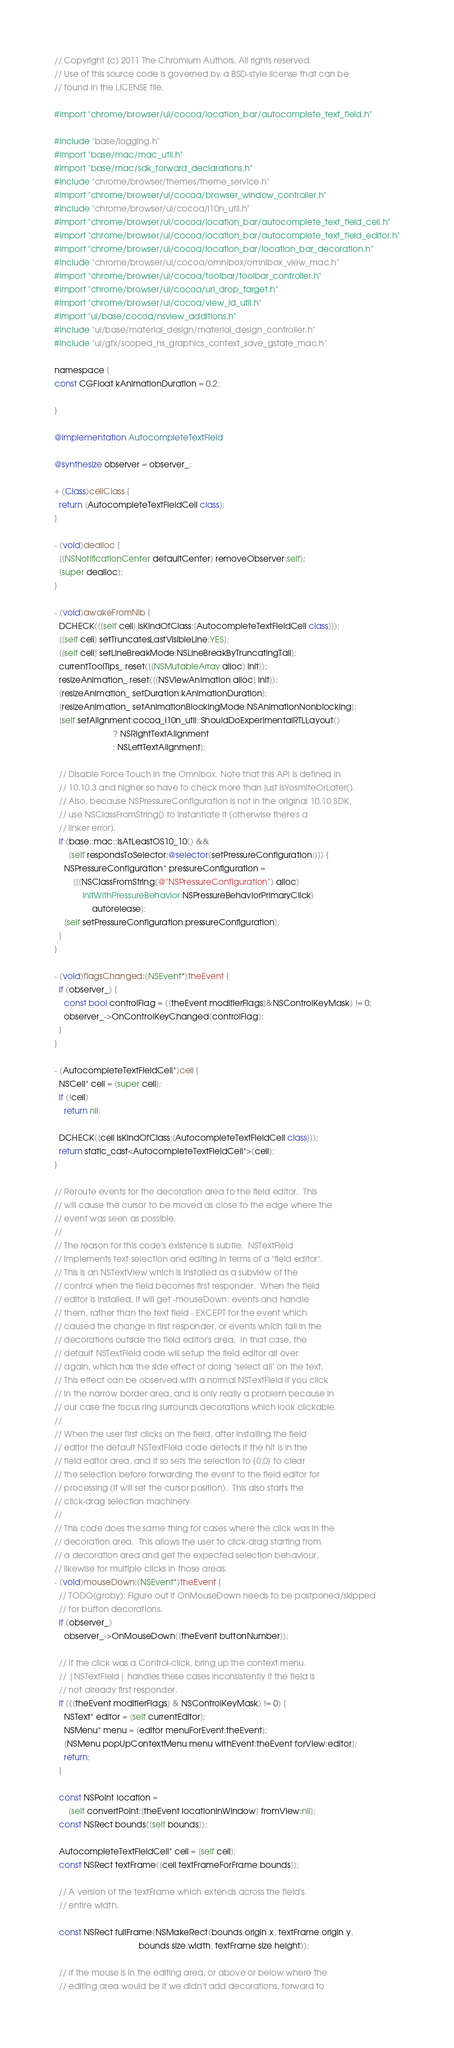<code> <loc_0><loc_0><loc_500><loc_500><_ObjectiveC_>// Copyright (c) 2011 The Chromium Authors. All rights reserved.
// Use of this source code is governed by a BSD-style license that can be
// found in the LICENSE file.

#import "chrome/browser/ui/cocoa/location_bar/autocomplete_text_field.h"

#include "base/logging.h"
#import "base/mac/mac_util.h"
#import "base/mac/sdk_forward_declarations.h"
#include "chrome/browser/themes/theme_service.h"
#import "chrome/browser/ui/cocoa/browser_window_controller.h"
#include "chrome/browser/ui/cocoa/l10n_util.h"
#import "chrome/browser/ui/cocoa/location_bar/autocomplete_text_field_cell.h"
#import "chrome/browser/ui/cocoa/location_bar/autocomplete_text_field_editor.h"
#import "chrome/browser/ui/cocoa/location_bar/location_bar_decoration.h"
#include "chrome/browser/ui/cocoa/omnibox/omnibox_view_mac.h"
#import "chrome/browser/ui/cocoa/toolbar/toolbar_controller.h"
#import "chrome/browser/ui/cocoa/url_drop_target.h"
#import "chrome/browser/ui/cocoa/view_id_util.h"
#import "ui/base/cocoa/nsview_additions.h"
#include "ui/base/material_design/material_design_controller.h"
#include "ui/gfx/scoped_ns_graphics_context_save_gstate_mac.h"

namespace {
const CGFloat kAnimationDuration = 0.2;

}

@implementation AutocompleteTextField

@synthesize observer = observer_;

+ (Class)cellClass {
  return [AutocompleteTextFieldCell class];
}

- (void)dealloc {
  [[NSNotificationCenter defaultCenter] removeObserver:self];
  [super dealloc];
}

- (void)awakeFromNib {
  DCHECK([[self cell] isKindOfClass:[AutocompleteTextFieldCell class]]);
  [[self cell] setTruncatesLastVisibleLine:YES];
  [[self cell] setLineBreakMode:NSLineBreakByTruncatingTail];
  currentToolTips_.reset([[NSMutableArray alloc] init]);
  resizeAnimation_.reset([[NSViewAnimation alloc] init]);
  [resizeAnimation_ setDuration:kAnimationDuration];
  [resizeAnimation_ setAnimationBlockingMode:NSAnimationNonblocking];
  [self setAlignment:cocoa_l10n_util::ShouldDoExperimentalRTLLayout()
                         ? NSRightTextAlignment
                         : NSLeftTextAlignment];

  // Disable Force Touch in the Omnibox. Note that this API is defined in
  // 10.10.3 and higher so have to check more than just isYosmiteOrLater().
  // Also, because NSPressureConfiguration is not in the original 10.10 SDK,
  // use NSClassFromString() to instantiate it (otherwise there's a
  // linker error).
  if (base::mac::IsAtLeastOS10_10() &&
      [self respondsToSelector:@selector(setPressureConfiguration:)]) {
    NSPressureConfiguration* pressureConfiguration =
        [[[NSClassFromString(@"NSPressureConfiguration") alloc]
            initWithPressureBehavior:NSPressureBehaviorPrimaryClick]
                autorelease];
    [self setPressureConfiguration:pressureConfiguration];
  }
}

- (void)flagsChanged:(NSEvent*)theEvent {
  if (observer_) {
    const bool controlFlag = ([theEvent modifierFlags]&NSControlKeyMask) != 0;
    observer_->OnControlKeyChanged(controlFlag);
  }
}

- (AutocompleteTextFieldCell*)cell {
  NSCell* cell = [super cell];
  if (!cell)
    return nil;

  DCHECK([cell isKindOfClass:[AutocompleteTextFieldCell class]]);
  return static_cast<AutocompleteTextFieldCell*>(cell);
}

// Reroute events for the decoration area to the field editor.  This
// will cause the cursor to be moved as close to the edge where the
// event was seen as possible.
//
// The reason for this code's existence is subtle.  NSTextField
// implements text selection and editing in terms of a "field editor".
// This is an NSTextView which is installed as a subview of the
// control when the field becomes first responder.  When the field
// editor is installed, it will get -mouseDown: events and handle
// them, rather than the text field - EXCEPT for the event which
// caused the change in first responder, or events which fall in the
// decorations outside the field editor's area.  In that case, the
// default NSTextField code will setup the field editor all over
// again, which has the side effect of doing "select all" on the text.
// This effect can be observed with a normal NSTextField if you click
// in the narrow border area, and is only really a problem because in
// our case the focus ring surrounds decorations which look clickable.
//
// When the user first clicks on the field, after installing the field
// editor the default NSTextField code detects if the hit is in the
// field editor area, and if so sets the selection to {0,0} to clear
// the selection before forwarding the event to the field editor for
// processing (it will set the cursor position).  This also starts the
// click-drag selection machinery.
//
// This code does the same thing for cases where the click was in the
// decoration area.  This allows the user to click-drag starting from
// a decoration area and get the expected selection behaviour,
// likewise for multiple clicks in those areas.
- (void)mouseDown:(NSEvent*)theEvent {
  // TODO(groby): Figure out if OnMouseDown needs to be postponed/skipped
  // for button decorations.
  if (observer_)
    observer_->OnMouseDown([theEvent buttonNumber]);

  // If the click was a Control-click, bring up the context menu.
  // |NSTextField| handles these cases inconsistently if the field is
  // not already first responder.
  if (([theEvent modifierFlags] & NSControlKeyMask) != 0) {
    NSText* editor = [self currentEditor];
    NSMenu* menu = [editor menuForEvent:theEvent];
    [NSMenu popUpContextMenu:menu withEvent:theEvent forView:editor];
    return;
  }

  const NSPoint location =
      [self convertPoint:[theEvent locationInWindow] fromView:nil];
  const NSRect bounds([self bounds]);

  AutocompleteTextFieldCell* cell = [self cell];
  const NSRect textFrame([cell textFrameForFrame:bounds]);

  // A version of the textFrame which extends across the field's
  // entire width.

  const NSRect fullFrame(NSMakeRect(bounds.origin.x, textFrame.origin.y,
                                    bounds.size.width, textFrame.size.height));

  // If the mouse is in the editing area, or above or below where the
  // editing area would be if we didn't add decorations, forward to</code> 